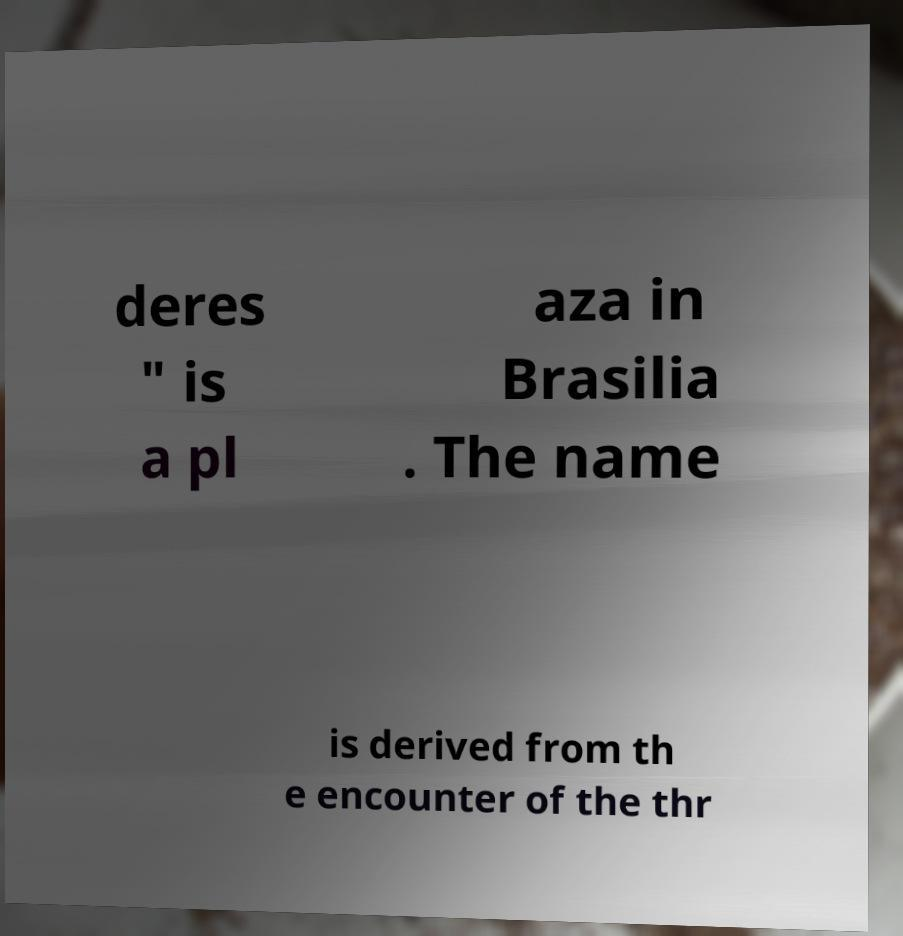Can you accurately transcribe the text from the provided image for me? deres " is a pl aza in Brasilia . The name is derived from th e encounter of the thr 